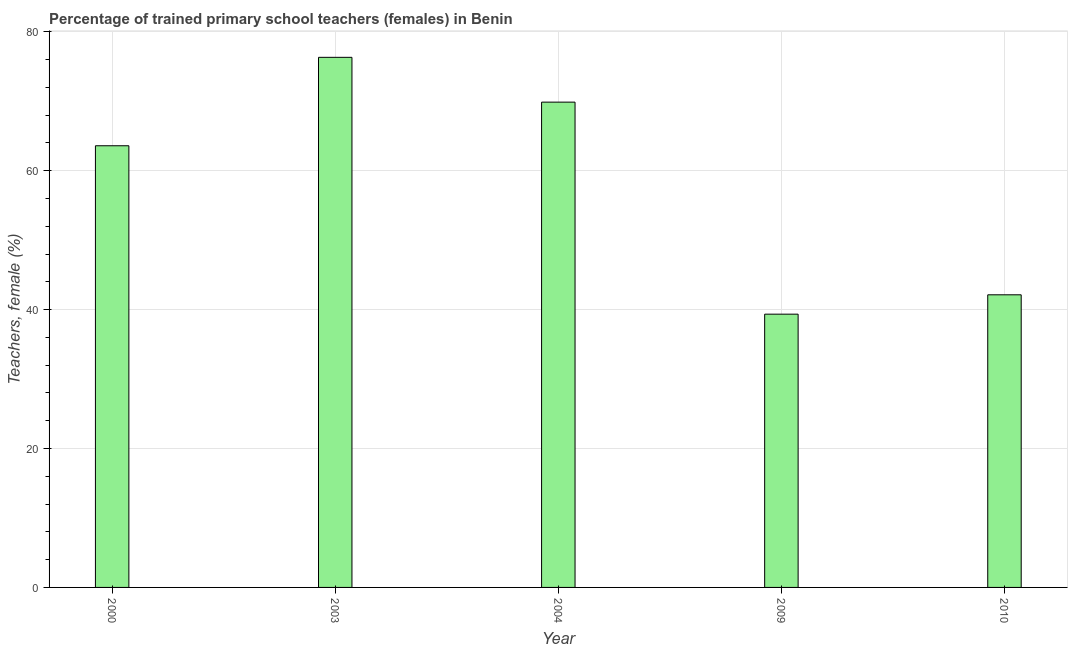What is the title of the graph?
Ensure brevity in your answer.  Percentage of trained primary school teachers (females) in Benin. What is the label or title of the Y-axis?
Your answer should be very brief. Teachers, female (%). What is the percentage of trained female teachers in 2003?
Make the answer very short. 76.33. Across all years, what is the maximum percentage of trained female teachers?
Your answer should be very brief. 76.33. Across all years, what is the minimum percentage of trained female teachers?
Make the answer very short. 39.35. In which year was the percentage of trained female teachers maximum?
Your response must be concise. 2003. What is the sum of the percentage of trained female teachers?
Keep it short and to the point. 291.3. What is the difference between the percentage of trained female teachers in 2004 and 2009?
Ensure brevity in your answer.  30.53. What is the average percentage of trained female teachers per year?
Your answer should be very brief. 58.26. What is the median percentage of trained female teachers?
Provide a short and direct response. 63.6. What is the ratio of the percentage of trained female teachers in 2003 to that in 2010?
Keep it short and to the point. 1.81. Is the difference between the percentage of trained female teachers in 2009 and 2010 greater than the difference between any two years?
Provide a succinct answer. No. What is the difference between the highest and the second highest percentage of trained female teachers?
Make the answer very short. 6.45. Is the sum of the percentage of trained female teachers in 2000 and 2009 greater than the maximum percentage of trained female teachers across all years?
Give a very brief answer. Yes. What is the difference between the highest and the lowest percentage of trained female teachers?
Provide a short and direct response. 36.98. In how many years, is the percentage of trained female teachers greater than the average percentage of trained female teachers taken over all years?
Your response must be concise. 3. Are all the bars in the graph horizontal?
Your answer should be very brief. No. What is the difference between two consecutive major ticks on the Y-axis?
Keep it short and to the point. 20. What is the Teachers, female (%) in 2000?
Give a very brief answer. 63.6. What is the Teachers, female (%) in 2003?
Your answer should be compact. 76.33. What is the Teachers, female (%) in 2004?
Your answer should be compact. 69.88. What is the Teachers, female (%) of 2009?
Offer a terse response. 39.35. What is the Teachers, female (%) in 2010?
Your answer should be very brief. 42.14. What is the difference between the Teachers, female (%) in 2000 and 2003?
Offer a terse response. -12.73. What is the difference between the Teachers, female (%) in 2000 and 2004?
Offer a very short reply. -6.28. What is the difference between the Teachers, female (%) in 2000 and 2009?
Provide a short and direct response. 24.25. What is the difference between the Teachers, female (%) in 2000 and 2010?
Your answer should be very brief. 21.46. What is the difference between the Teachers, female (%) in 2003 and 2004?
Make the answer very short. 6.45. What is the difference between the Teachers, female (%) in 2003 and 2009?
Make the answer very short. 36.98. What is the difference between the Teachers, female (%) in 2003 and 2010?
Provide a succinct answer. 34.19. What is the difference between the Teachers, female (%) in 2004 and 2009?
Your answer should be very brief. 30.53. What is the difference between the Teachers, female (%) in 2004 and 2010?
Give a very brief answer. 27.74. What is the difference between the Teachers, female (%) in 2009 and 2010?
Your answer should be very brief. -2.79. What is the ratio of the Teachers, female (%) in 2000 to that in 2003?
Your answer should be compact. 0.83. What is the ratio of the Teachers, female (%) in 2000 to that in 2004?
Give a very brief answer. 0.91. What is the ratio of the Teachers, female (%) in 2000 to that in 2009?
Make the answer very short. 1.62. What is the ratio of the Teachers, female (%) in 2000 to that in 2010?
Your answer should be compact. 1.51. What is the ratio of the Teachers, female (%) in 2003 to that in 2004?
Ensure brevity in your answer.  1.09. What is the ratio of the Teachers, female (%) in 2003 to that in 2009?
Provide a succinct answer. 1.94. What is the ratio of the Teachers, female (%) in 2003 to that in 2010?
Offer a terse response. 1.81. What is the ratio of the Teachers, female (%) in 2004 to that in 2009?
Provide a succinct answer. 1.78. What is the ratio of the Teachers, female (%) in 2004 to that in 2010?
Your response must be concise. 1.66. What is the ratio of the Teachers, female (%) in 2009 to that in 2010?
Keep it short and to the point. 0.93. 